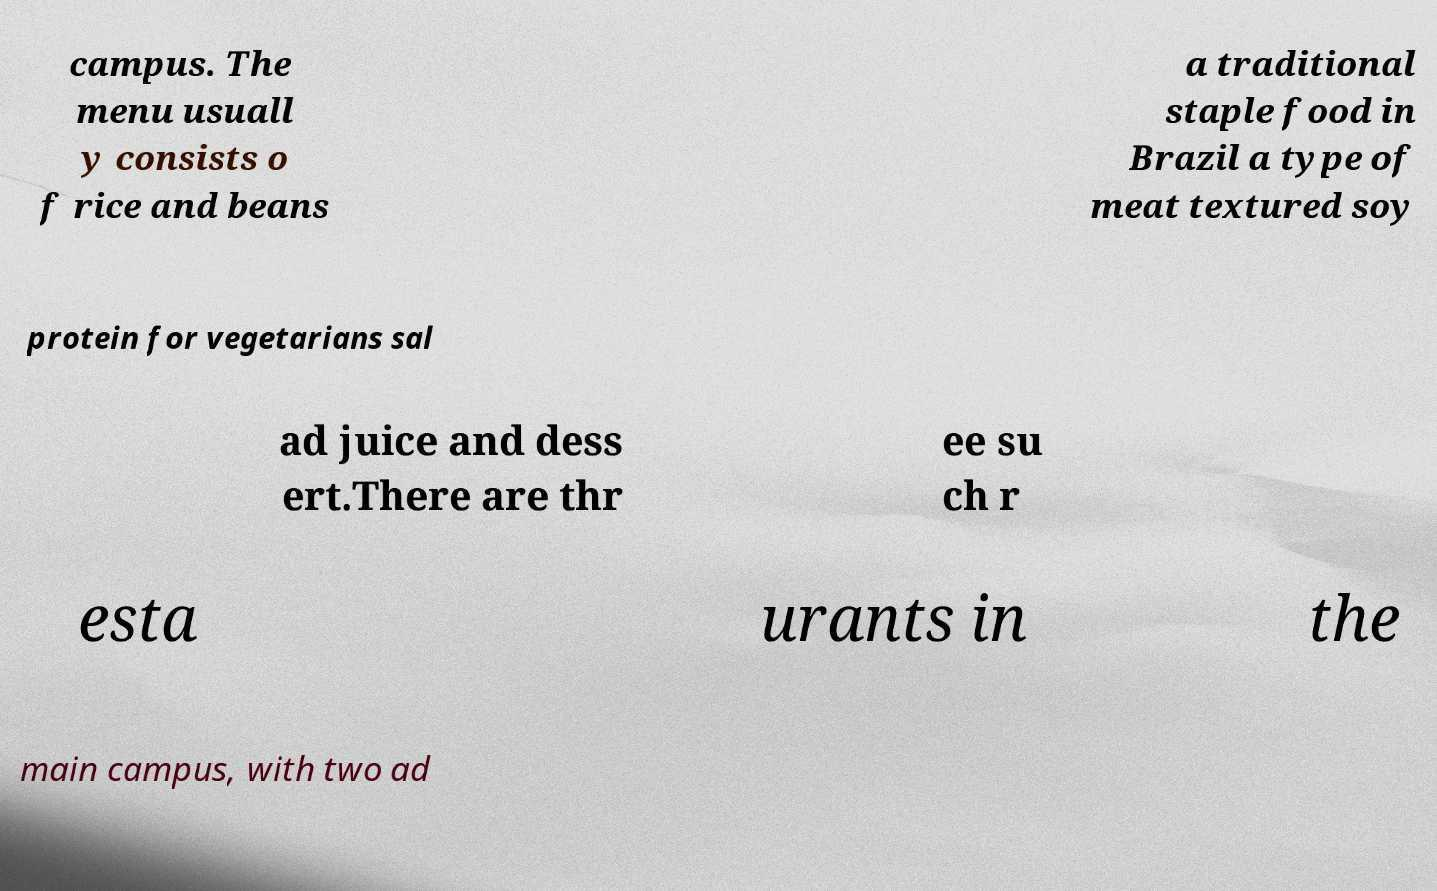What messages or text are displayed in this image? I need them in a readable, typed format. campus. The menu usuall y consists o f rice and beans a traditional staple food in Brazil a type of meat textured soy protein for vegetarians sal ad juice and dess ert.There are thr ee su ch r esta urants in the main campus, with two ad 